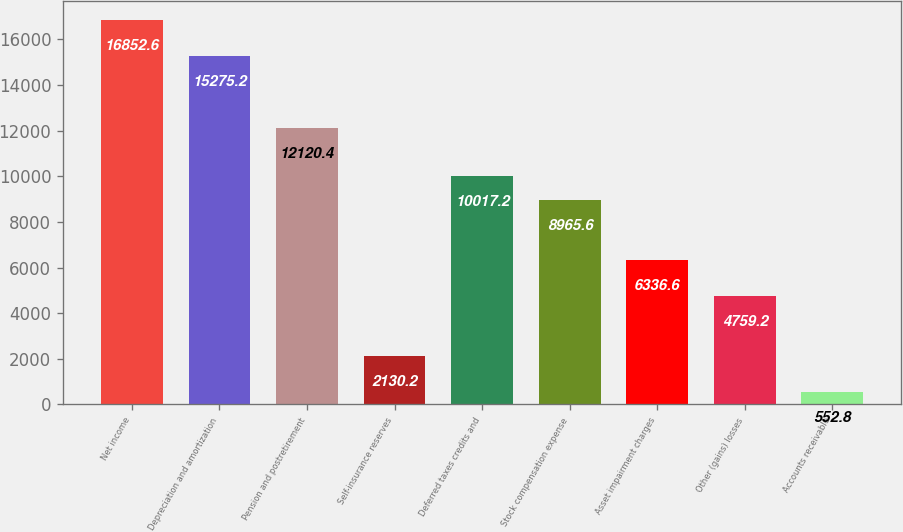<chart> <loc_0><loc_0><loc_500><loc_500><bar_chart><fcel>Net income<fcel>Depreciation and amortization<fcel>Pension and postretirement<fcel>Self-insurance reserves<fcel>Deferred taxes credits and<fcel>Stock compensation expense<fcel>Asset impairment charges<fcel>Other (gains) losses<fcel>Accounts receivable<nl><fcel>16852.6<fcel>15275.2<fcel>12120.4<fcel>2130.2<fcel>10017.2<fcel>8965.6<fcel>6336.6<fcel>4759.2<fcel>552.8<nl></chart> 